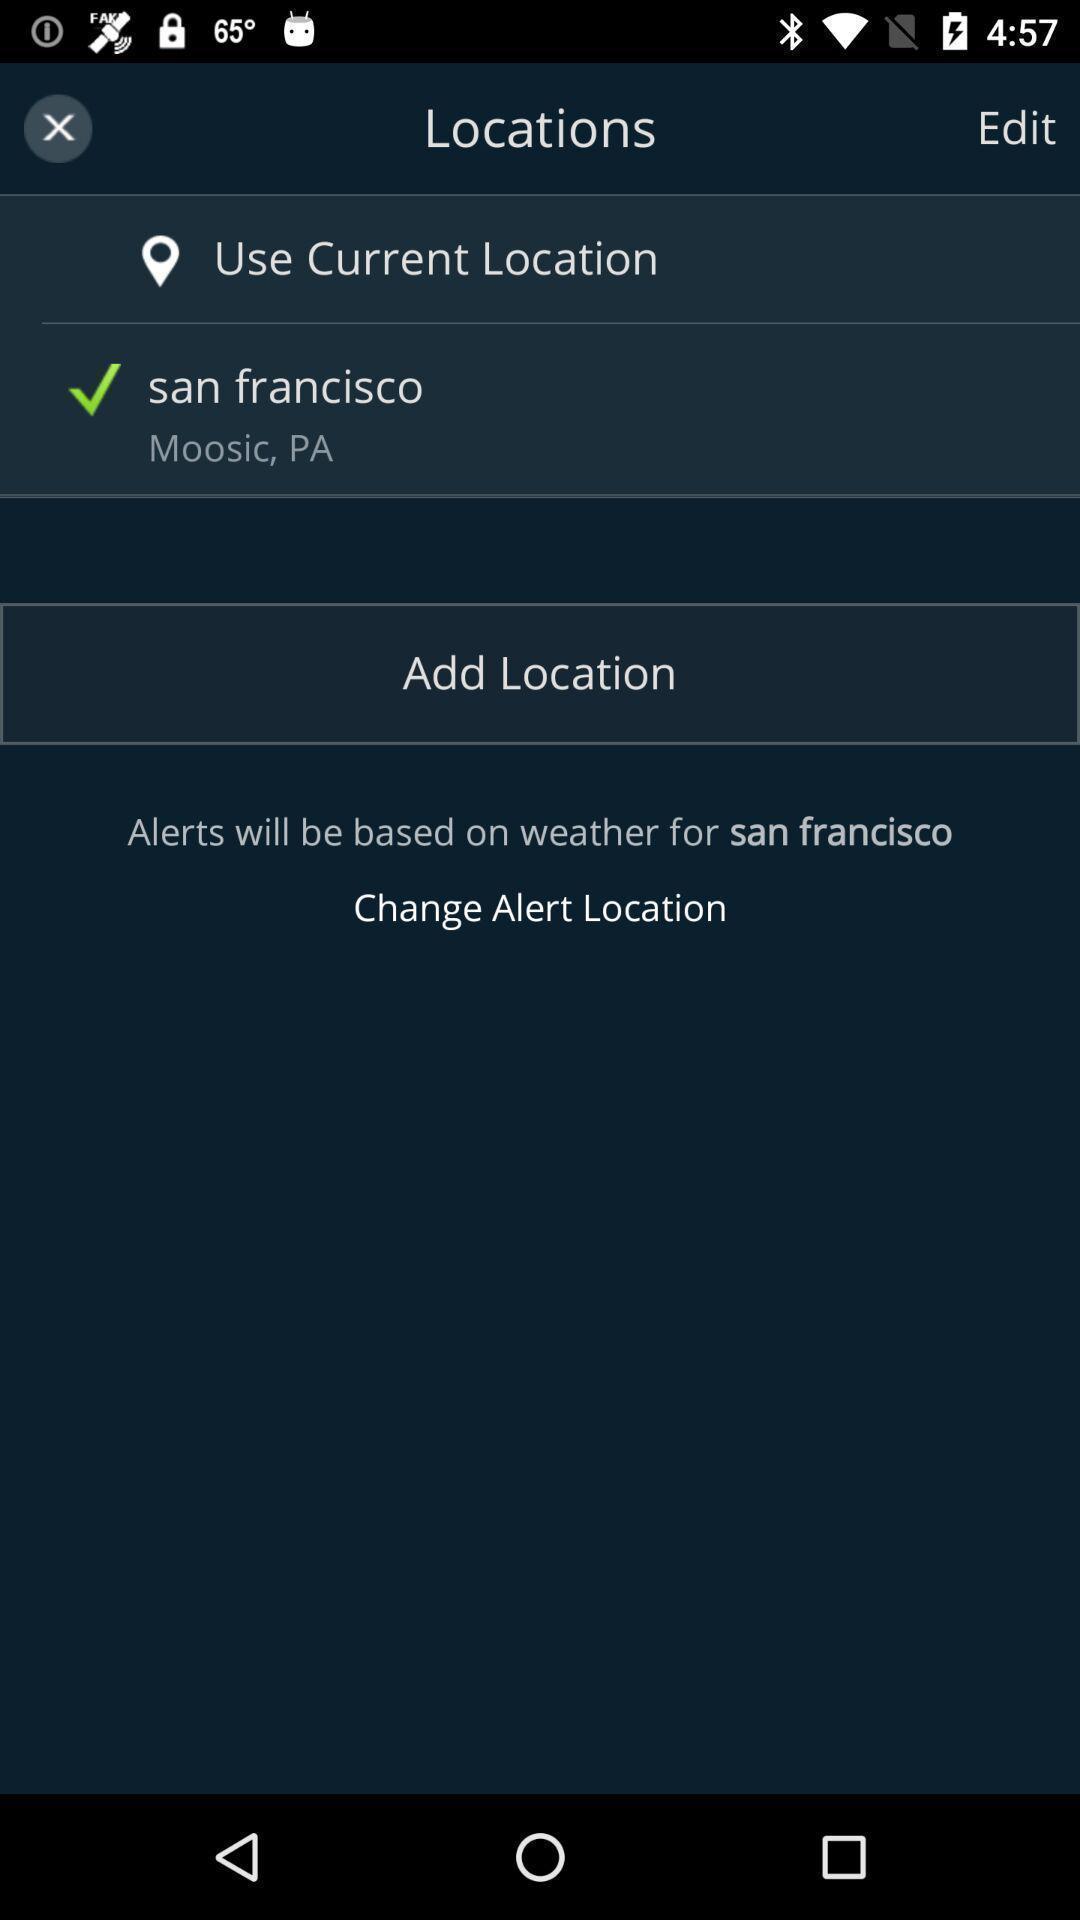Summarize the information in this screenshot. Screen showing to add the current location. 